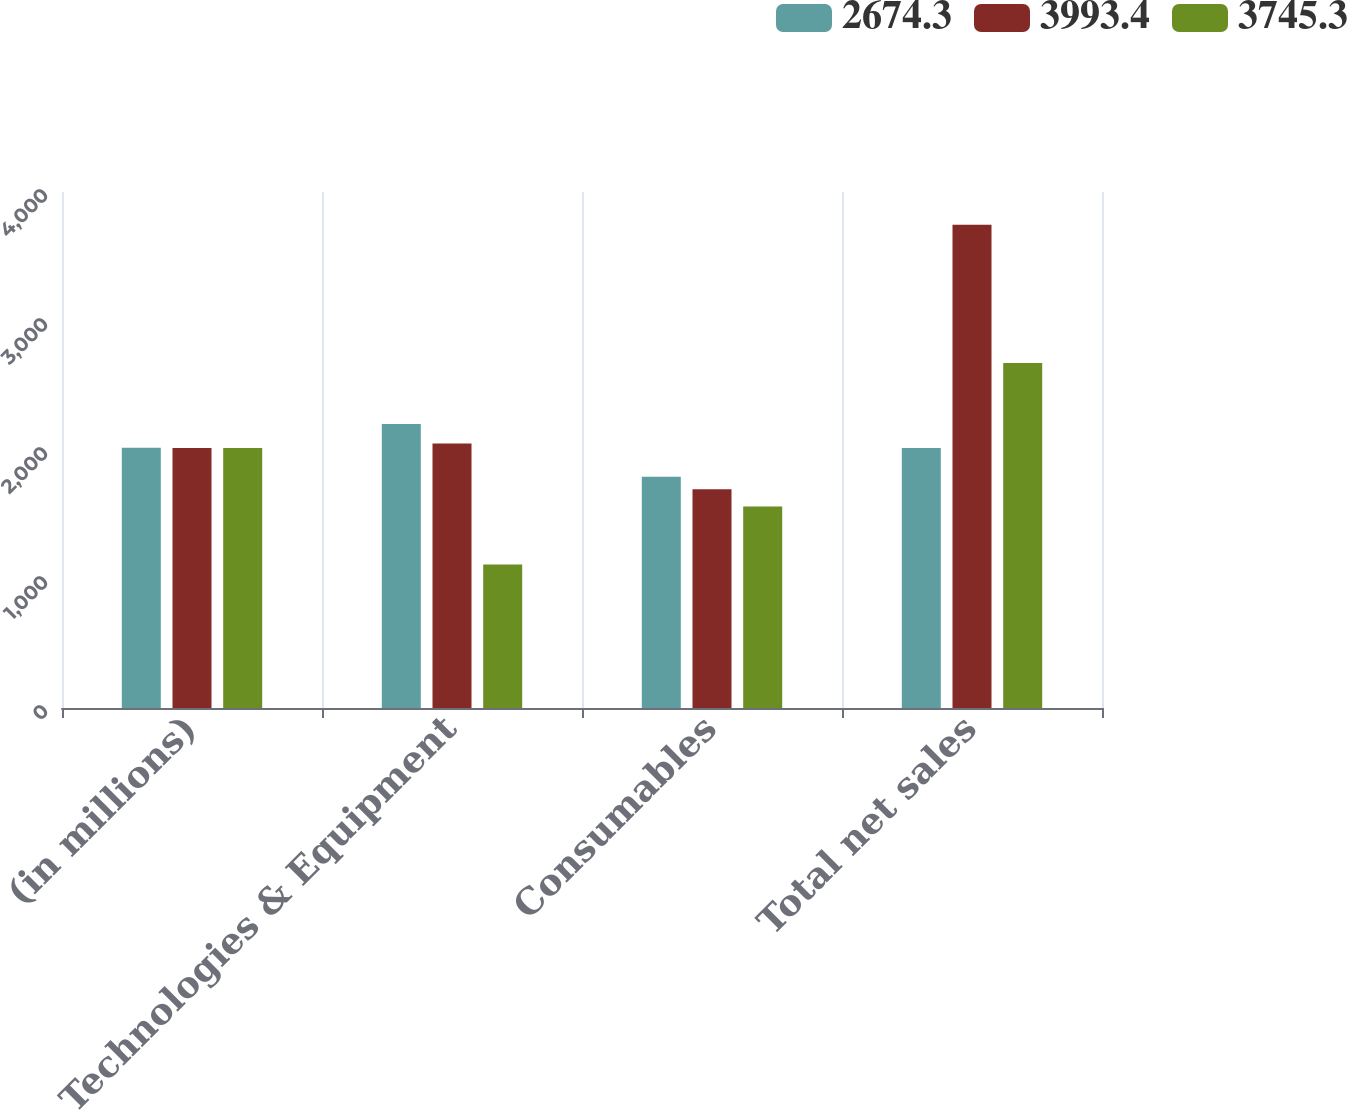Convert chart. <chart><loc_0><loc_0><loc_500><loc_500><stacked_bar_chart><ecel><fcel>(in millions)<fcel>Technologies & Equipment<fcel>Consumables<fcel>Total net sales<nl><fcel>2674.3<fcel>2017<fcel>2200.8<fcel>1792.6<fcel>2016<nl><fcel>3993.4<fcel>2016<fcel>2050.5<fcel>1694.8<fcel>3745.3<nl><fcel>3745.3<fcel>2015<fcel>1112.7<fcel>1561.6<fcel>2674.3<nl></chart> 